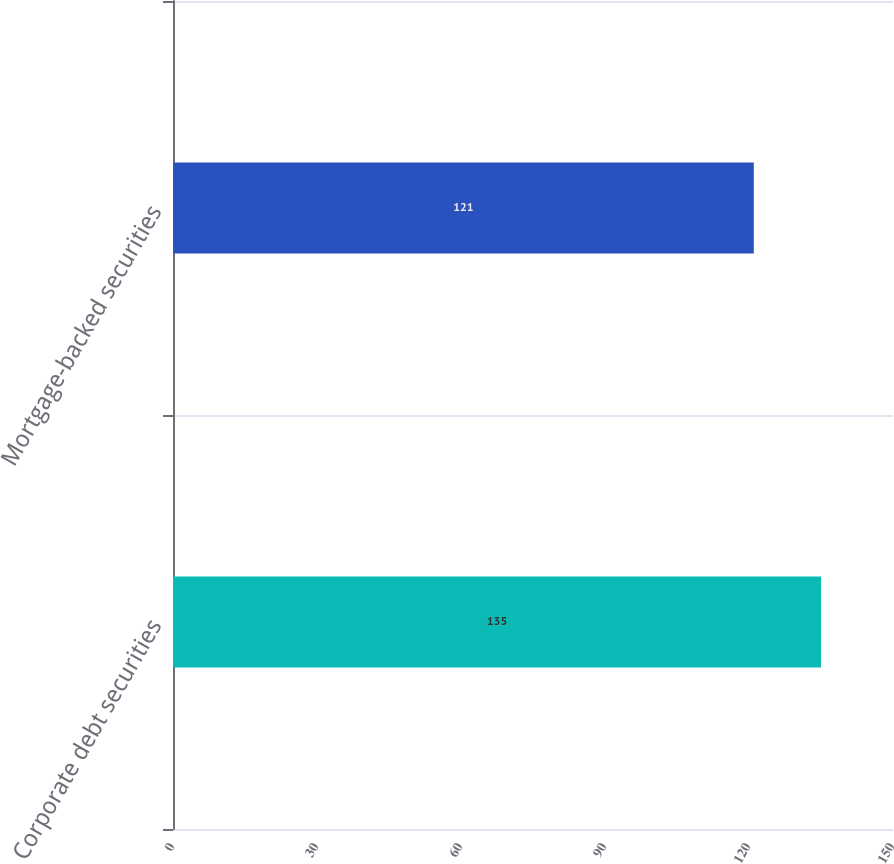Convert chart. <chart><loc_0><loc_0><loc_500><loc_500><bar_chart><fcel>Corporate debt securities<fcel>Mortgage-backed securities<nl><fcel>135<fcel>121<nl></chart> 